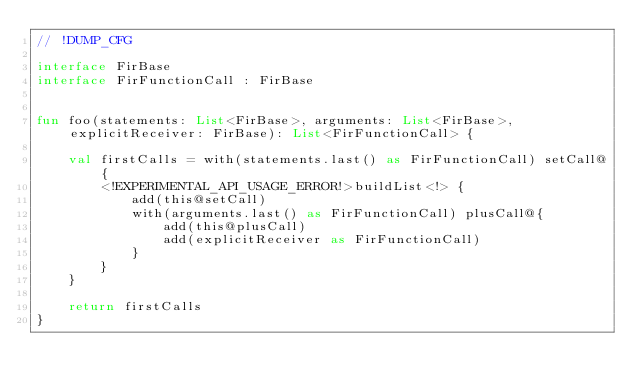Convert code to text. <code><loc_0><loc_0><loc_500><loc_500><_Kotlin_>// !DUMP_CFG

interface FirBase
interface FirFunctionCall : FirBase


fun foo(statements: List<FirBase>, arguments: List<FirBase>, explicitReceiver: FirBase): List<FirFunctionCall> {

    val firstCalls = with(statements.last() as FirFunctionCall) setCall@{
        <!EXPERIMENTAL_API_USAGE_ERROR!>buildList<!> {
            add(this@setCall)
            with(arguments.last() as FirFunctionCall) plusCall@{
                add(this@plusCall)
                add(explicitReceiver as FirFunctionCall)
            }
        }
    }

    return firstCalls
}</code> 